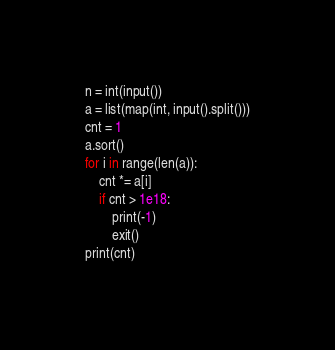Convert code to text. <code><loc_0><loc_0><loc_500><loc_500><_Python_>n = int(input())
a = list(map(int, input().split()))
cnt = 1
a.sort()
for i in range(len(a)):
    cnt *= a[i]
    if cnt > 1e18:
        print(-1)
        exit()
print(cnt)</code> 